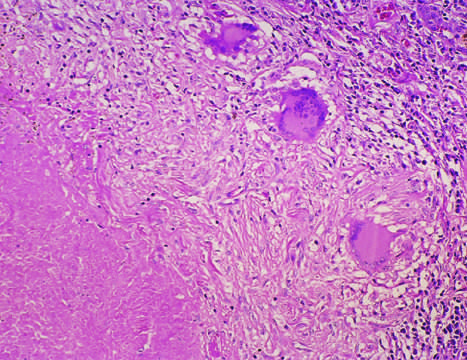what is the usual response in individuals who develop cell-mediated immunity to the organism?
Answer the question using a single word or phrase. Central granular caseation 